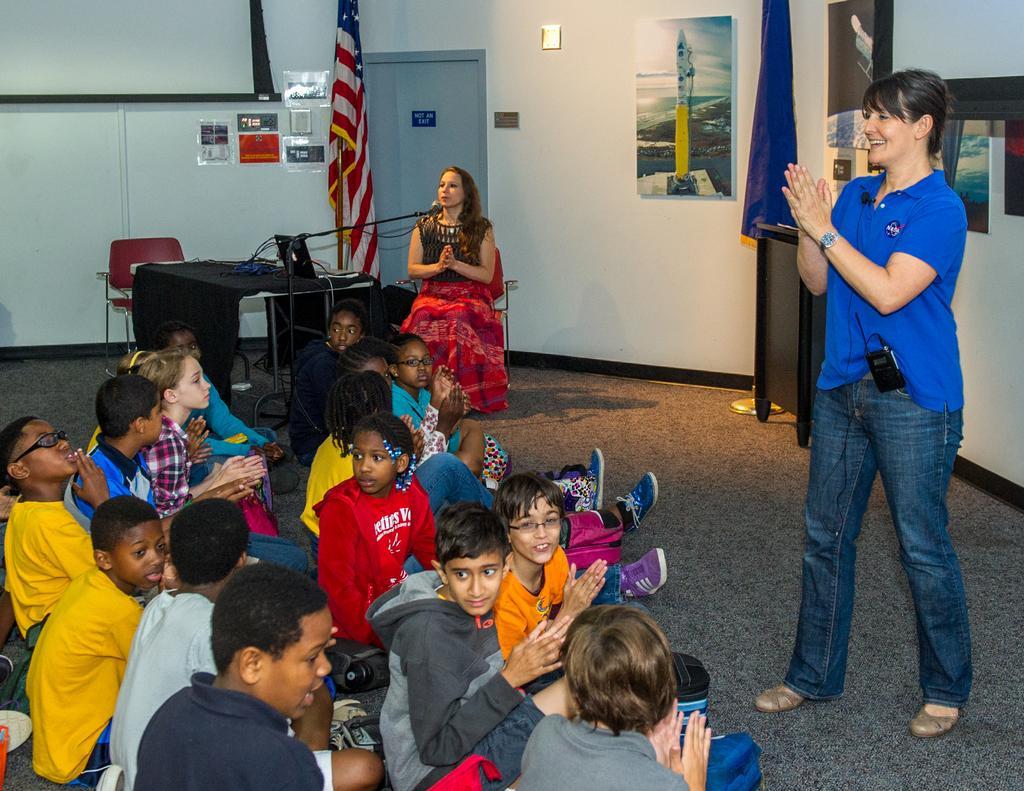Describe this image in one or two sentences. In this image there are group of persons standing and sitting. On the right side there is a person standing and smiling and in the background there is a table, on the table there are objects which are black in colour and there is a woman sitting and in front of the woman there is a mic and behind the woman there are flags, there is a door and there are frames on the wall and there is an empty chair which is red in colour. 